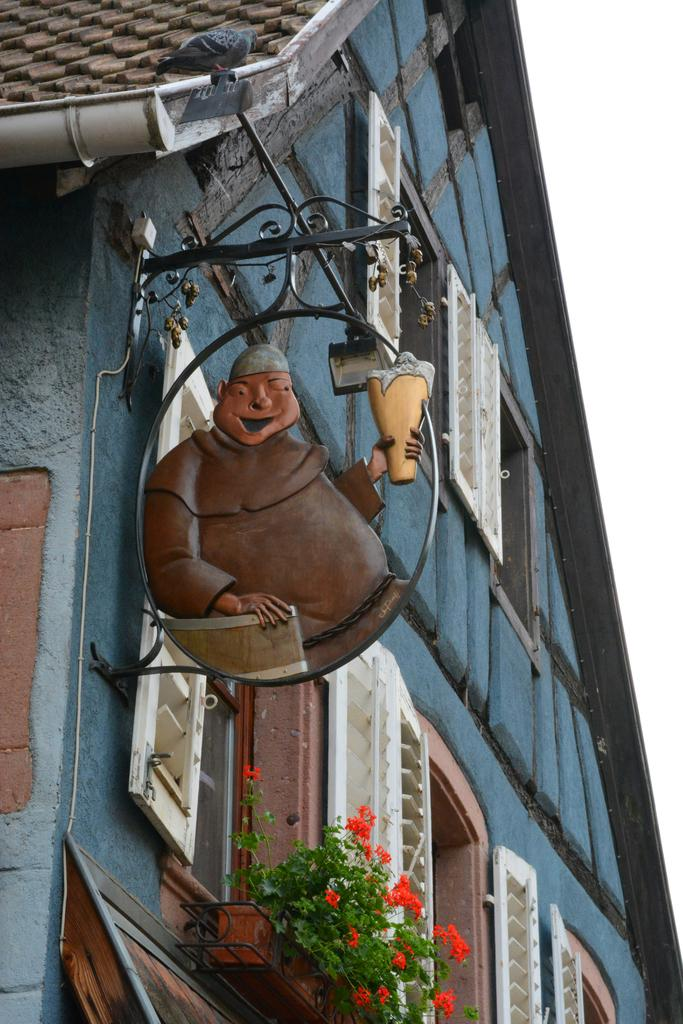What type of structure is present in the image? There is a house in the image. What features can be observed on the house? The house has windows and a roof. What else is present in the image besides the house? There is a decor with a stand and plants with flowers in the image. How many pizzas are being held by the dolls in the image? There are no dolls or pizzas present in the image. 